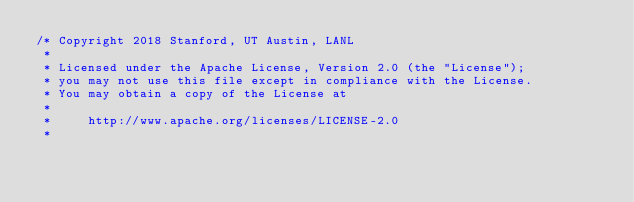<code> <loc_0><loc_0><loc_500><loc_500><_Cuda_>/* Copyright 2018 Stanford, UT Austin, LANL
 *
 * Licensed under the Apache License, Version 2.0 (the "License");
 * you may not use this file except in compliance with the License.
 * You may obtain a copy of the License at
 *
 *     http://www.apache.org/licenses/LICENSE-2.0
 *</code> 